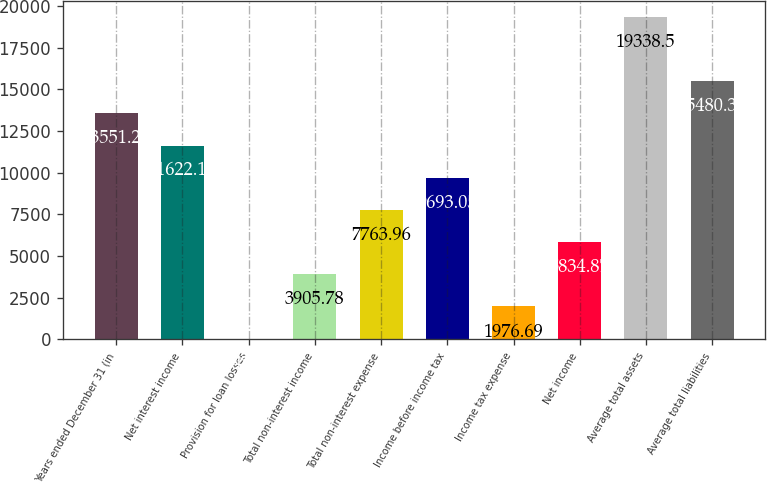<chart> <loc_0><loc_0><loc_500><loc_500><bar_chart><fcel>Years ended December 31 (in<fcel>Net interest income<fcel>Provision for loan losses<fcel>Total non-interest income<fcel>Total non-interest expense<fcel>Income before income tax<fcel>Income tax expense<fcel>Net income<fcel>Average total assets<fcel>Average total liabilities<nl><fcel>13551.2<fcel>11622.1<fcel>47.6<fcel>3905.78<fcel>7763.96<fcel>9693.05<fcel>1976.69<fcel>5834.87<fcel>19338.5<fcel>15480.3<nl></chart> 